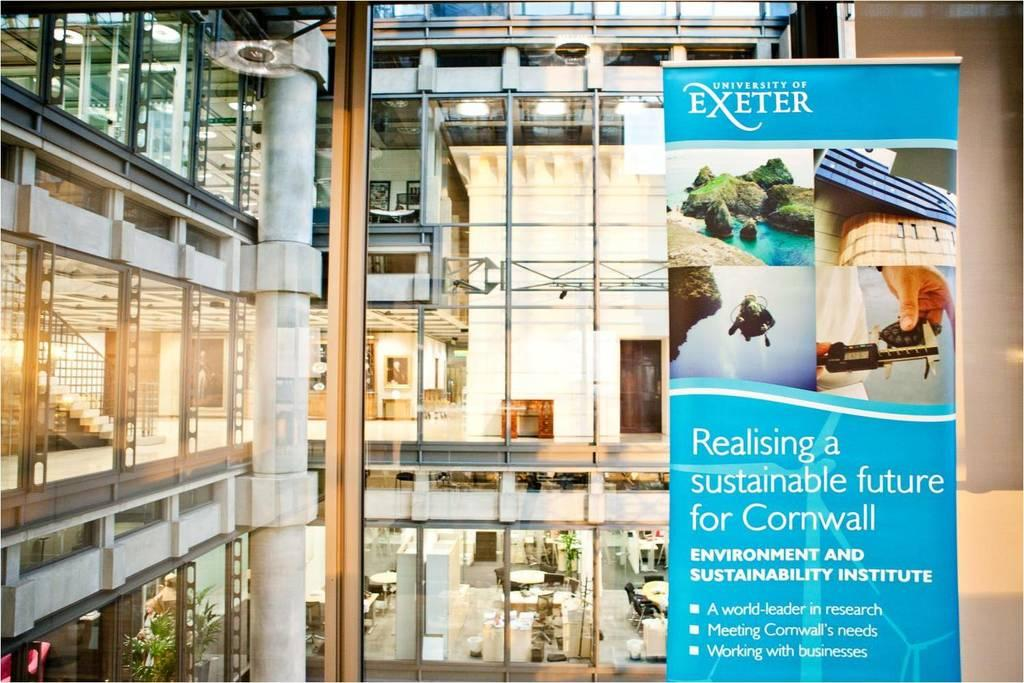<image>
Create a compact narrative representing the image presented. Store with a banner that says "University of Exeter". 